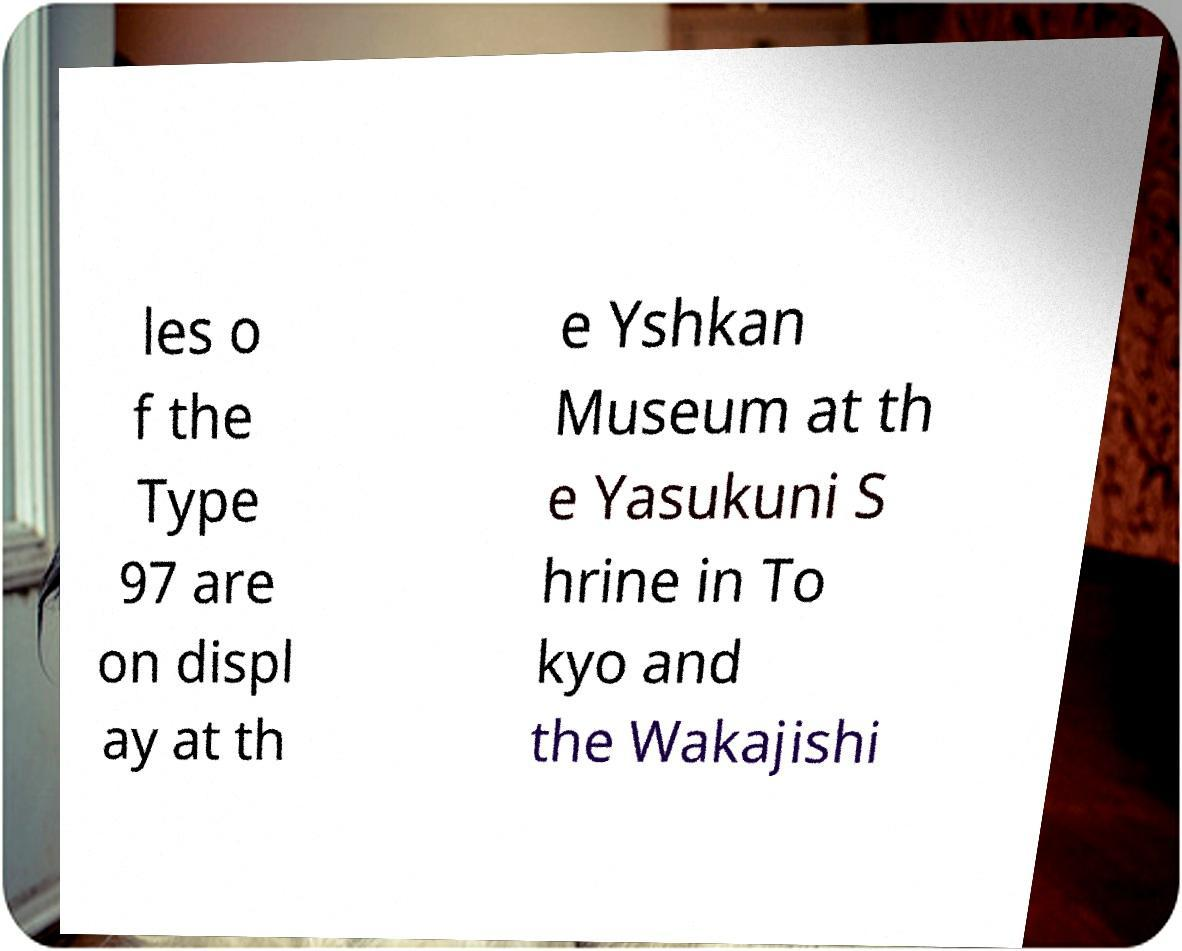I need the written content from this picture converted into text. Can you do that? les o f the Type 97 are on displ ay at th e Yshkan Museum at th e Yasukuni S hrine in To kyo and the Wakajishi 